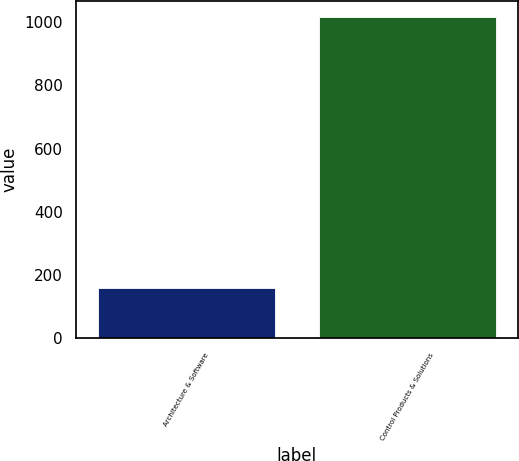Convert chart to OTSL. <chart><loc_0><loc_0><loc_500><loc_500><bar_chart><fcel>Architecture & Software<fcel>Control Products & Solutions<nl><fcel>160.3<fcel>1016.8<nl></chart> 